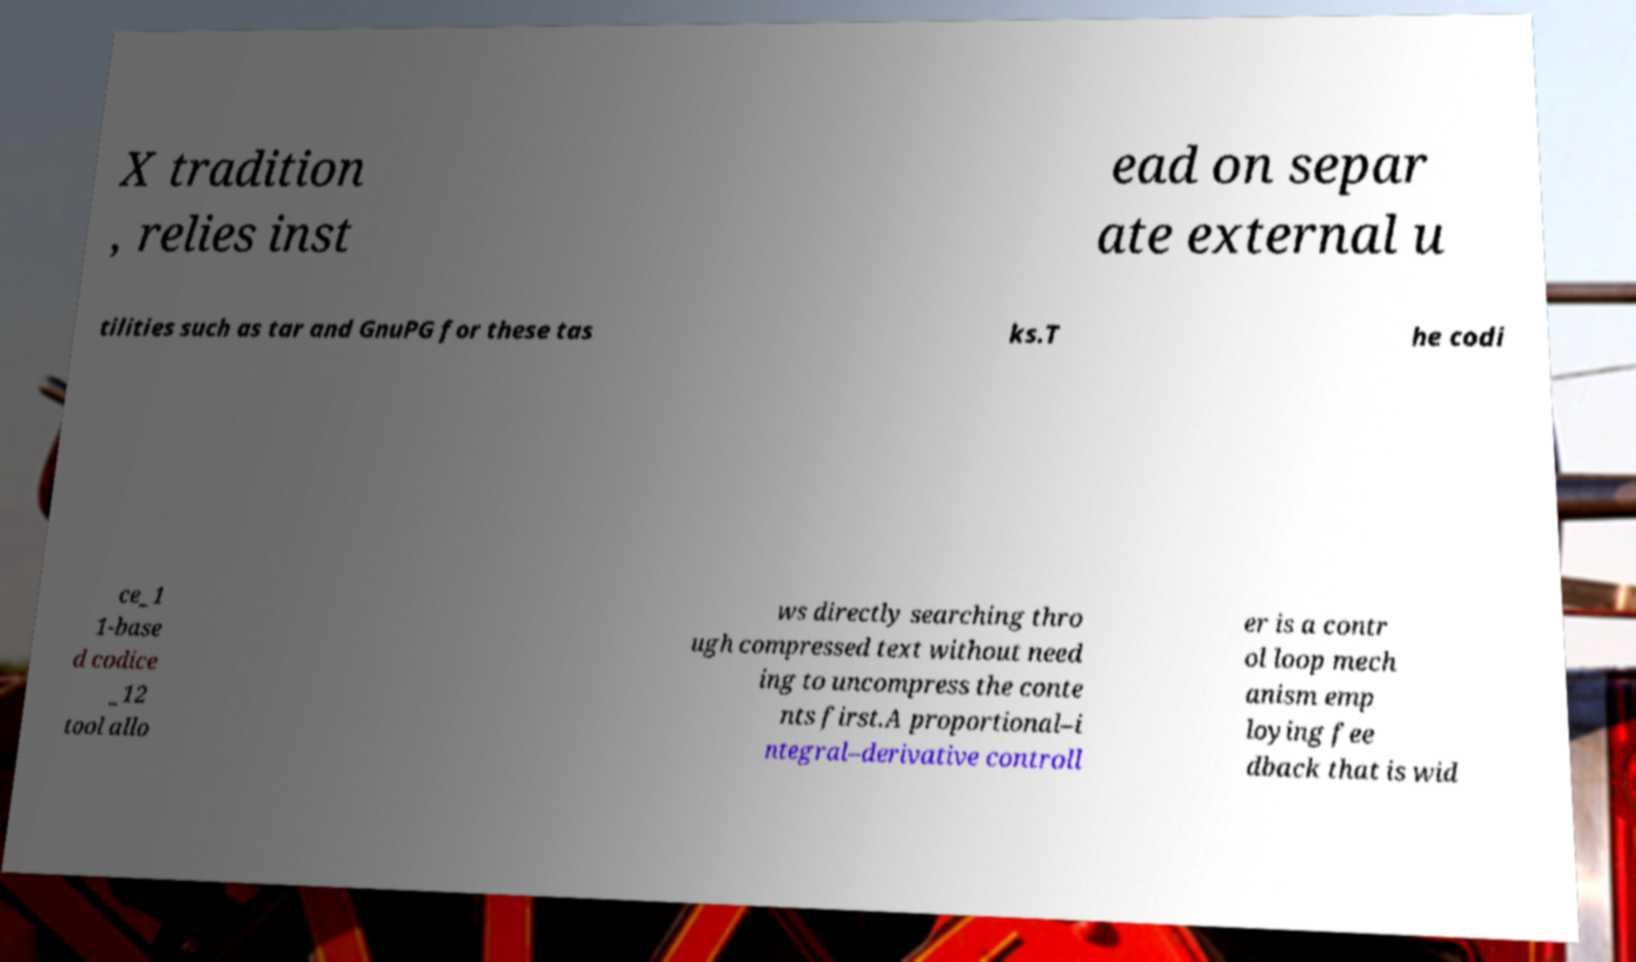I need the written content from this picture converted into text. Can you do that? X tradition , relies inst ead on separ ate external u tilities such as tar and GnuPG for these tas ks.T he codi ce_1 1-base d codice _12 tool allo ws directly searching thro ugh compressed text without need ing to uncompress the conte nts first.A proportional–i ntegral–derivative controll er is a contr ol loop mech anism emp loying fee dback that is wid 